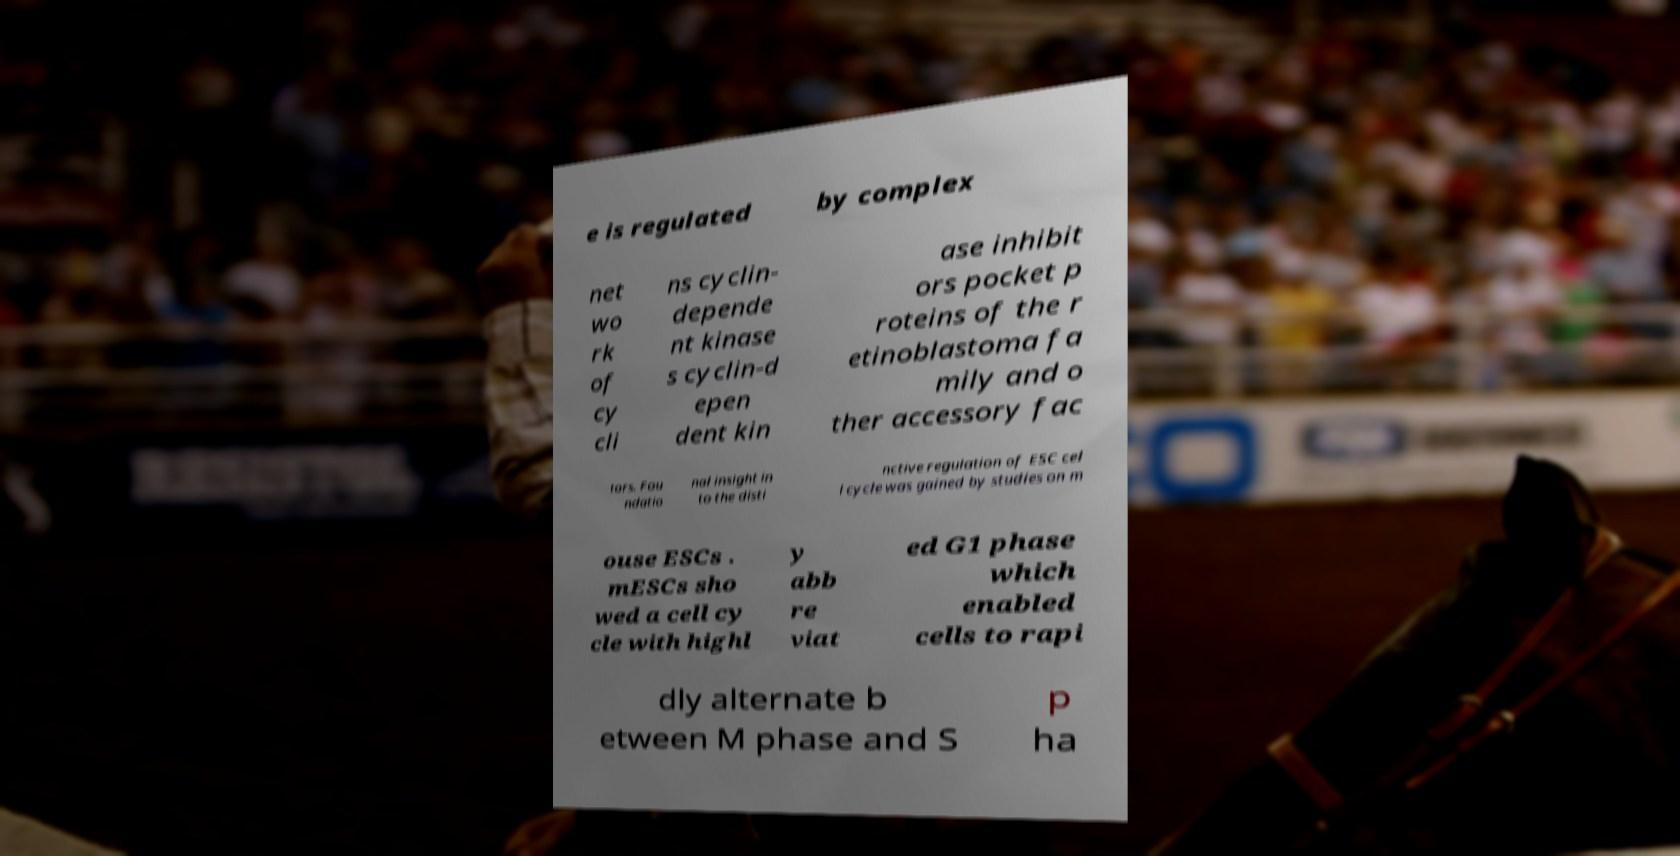Could you extract and type out the text from this image? e is regulated by complex net wo rk of cy cli ns cyclin- depende nt kinase s cyclin-d epen dent kin ase inhibit ors pocket p roteins of the r etinoblastoma fa mily and o ther accessory fac tors. Fou ndatio nal insight in to the disti nctive regulation of ESC cel l cycle was gained by studies on m ouse ESCs . mESCs sho wed a cell cy cle with highl y abb re viat ed G1 phase which enabled cells to rapi dly alternate b etween M phase and S p ha 